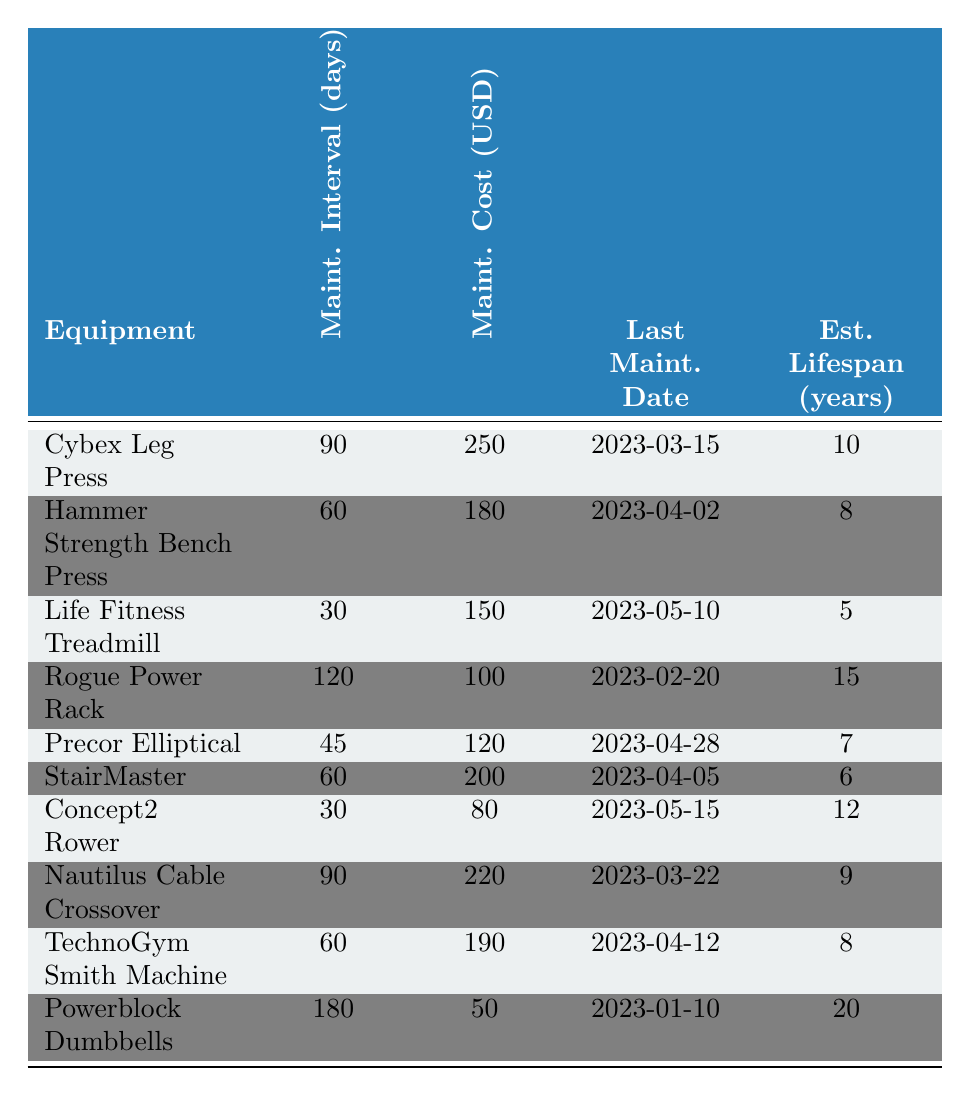What is the maintenance cost for the Life Fitness Treadmill? The table lists the maintenance cost for the Life Fitness Treadmill as 150 USD.
Answer: 150 USD How often does the Concept2 Rower need maintenance? According to the table, the maintenance interval for the Concept2 Rower is 30 days.
Answer: 30 days What is the last maintenance date for the StairMaster? The last maintenance date for the StairMaster, as noted in the table, is 2023-04-05.
Answer: 2023-04-05 Which equipment has the highest maintenance cost? By reviewing the table, the Nautilus Cable Crossover has the highest maintenance cost at 220 USD.
Answer: Nautilus Cable Crossover What is the average maintenance cost for the equipment? The total maintenance cost is 1,390 USD (250 + 180 + 150 + 100 + 120 + 200 + 80 + 220 + 190 + 50 = 1,390) and there are 10 pieces of equipment, so the average cost is 1,390 / 10 = 139 USD.
Answer: 139 USD Is the maintenance interval for the Powerblock Dumbbells longer than that for the Cybex Leg Press? The table shows that the Powerblock Dumbbells require maintenance every 180 days while the Cybex Leg Press needs it every 90 days, so the Powerblock Dumbbells have a longer interval.
Answer: Yes How many pieces of equipment require maintenance every 60 days or less? The equipment that requires maintenance every 60 days or less includes the Life Fitness Treadmill, Concept2 Rower, and StairMaster. This totals three pieces of equipment.
Answer: 3 What is the difference in maintenance cost between the Hammer Strength Bench Press and Precor Elliptical? The maintenance cost for Hammer Strength Bench Press is 180 USD and for Precor Elliptical is 120 USD. The difference is 180 - 120 = 60 USD.
Answer: 60 USD Which equipment has the longest estimated lifespan? The Powerblock Dumbbells have the longest estimated lifespan of 20 years, according to the table.
Answer: Powerblock Dumbbells What is the total maintenance cost for all equipment that needs to be serviced more frequently than every 60 days? The equipment serviced more frequently than every 60 days includes Life Fitness Treadmill (150 USD), Concept2 Rower (80 USD), and StairMaster (200 USD). Their total maintenance cost is 150 + 80 + 200 = 430 USD.
Answer: 430 USD 